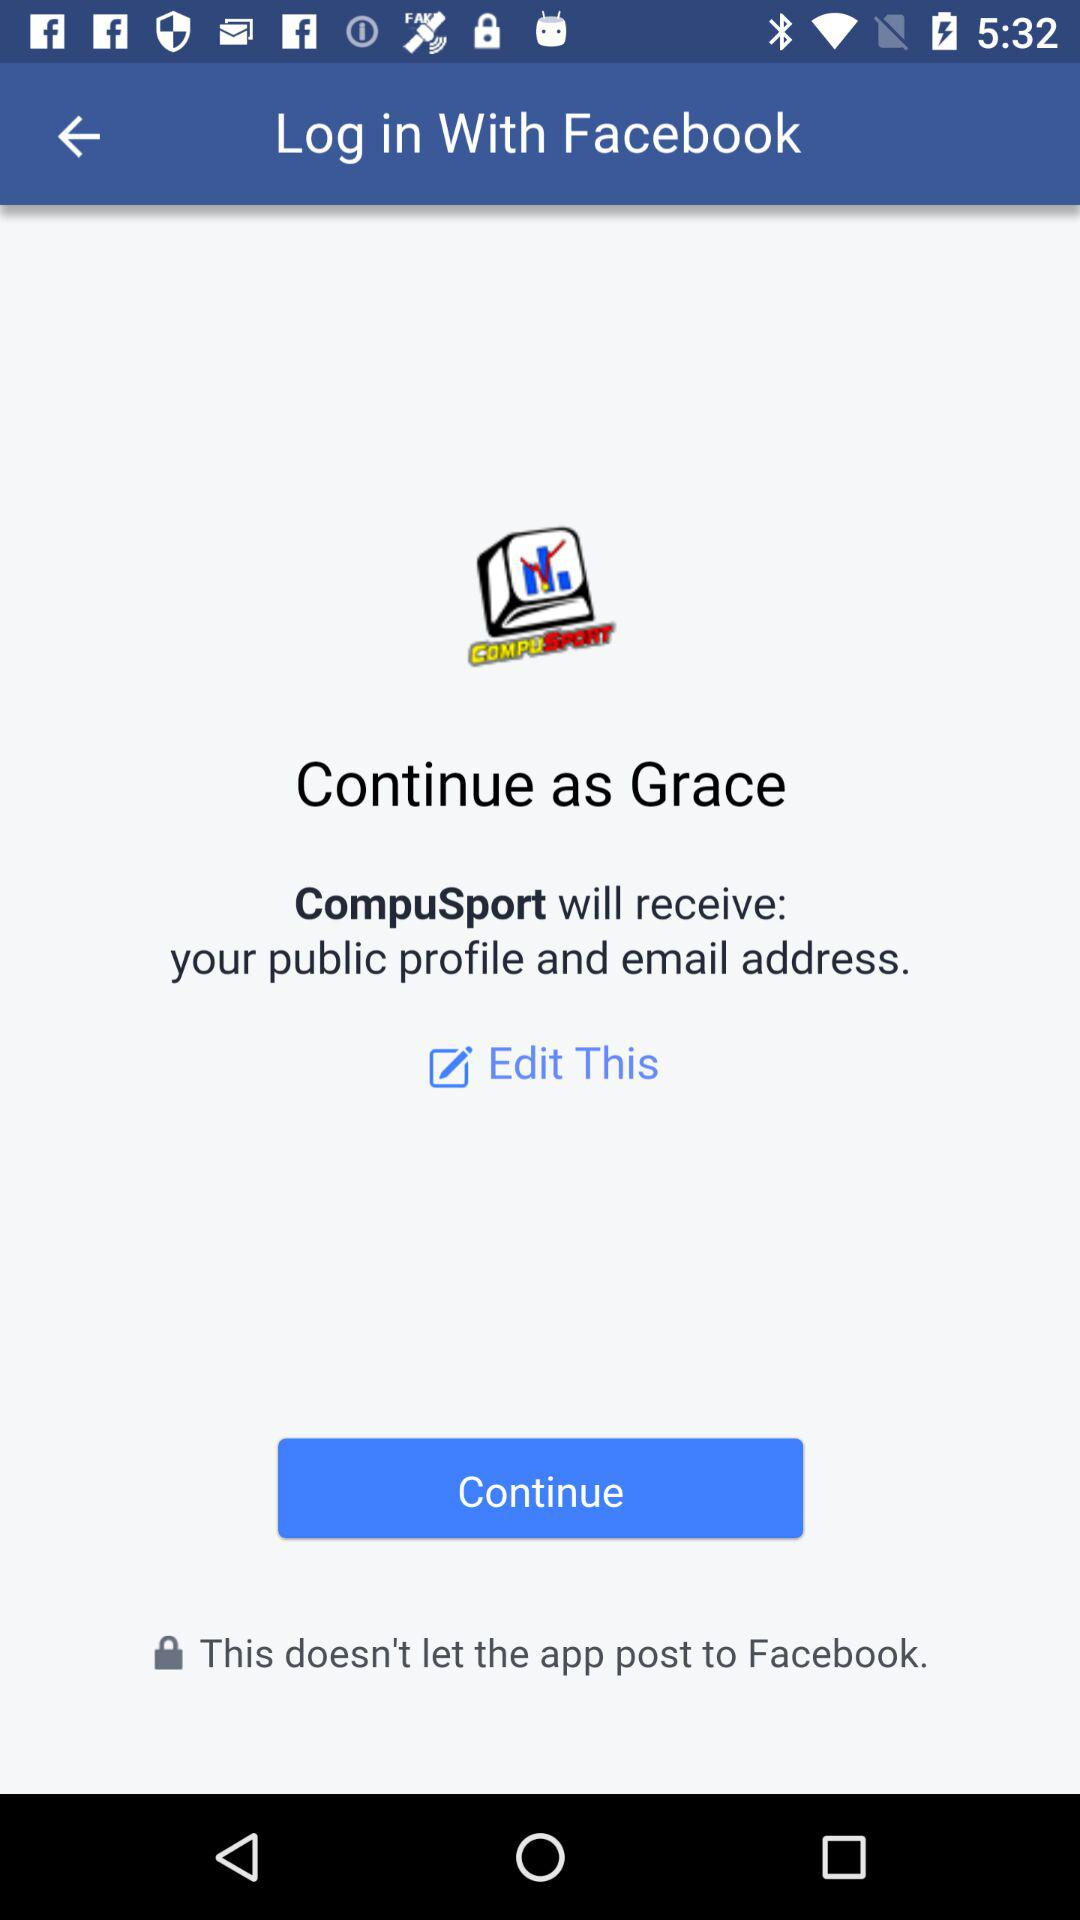What is the name of the user? The name of the user is Grace. 